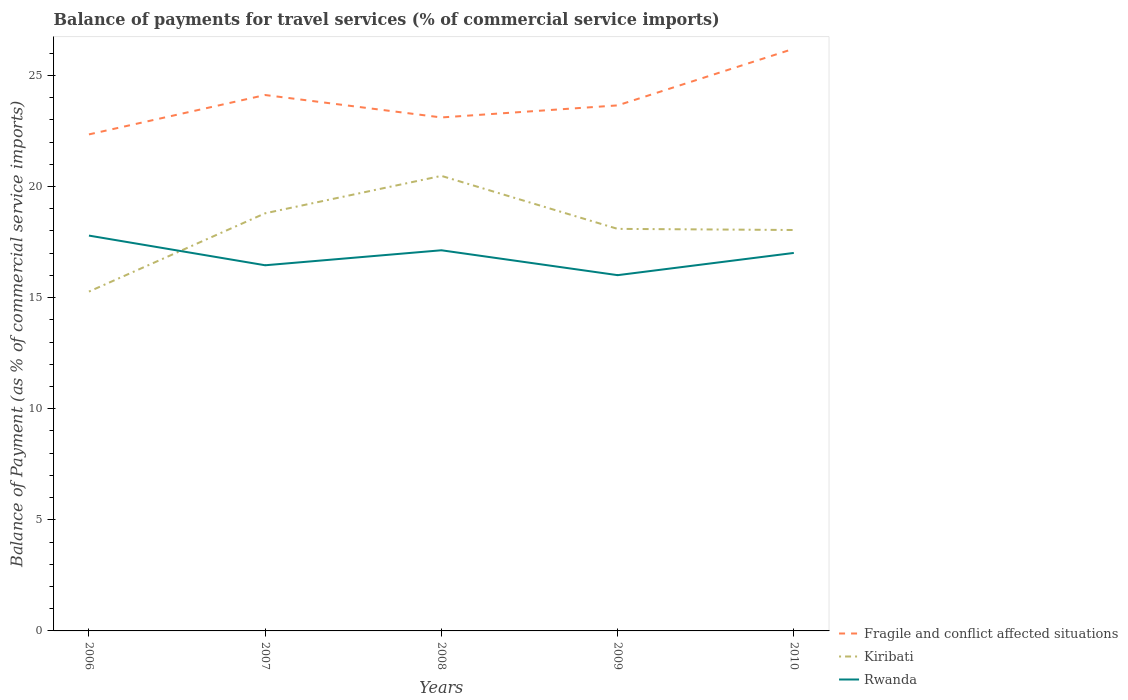How many different coloured lines are there?
Keep it short and to the point. 3. Does the line corresponding to Fragile and conflict affected situations intersect with the line corresponding to Rwanda?
Offer a very short reply. No. Is the number of lines equal to the number of legend labels?
Provide a succinct answer. Yes. Across all years, what is the maximum balance of payments for travel services in Kiribati?
Your answer should be compact. 15.27. In which year was the balance of payments for travel services in Fragile and conflict affected situations maximum?
Keep it short and to the point. 2006. What is the total balance of payments for travel services in Kiribati in the graph?
Provide a short and direct response. 2.38. What is the difference between the highest and the second highest balance of payments for travel services in Kiribati?
Give a very brief answer. 5.21. What is the difference between the highest and the lowest balance of payments for travel services in Kiribati?
Make the answer very short. 2. How many lines are there?
Give a very brief answer. 3. What is the difference between two consecutive major ticks on the Y-axis?
Your response must be concise. 5. Are the values on the major ticks of Y-axis written in scientific E-notation?
Offer a very short reply. No. Where does the legend appear in the graph?
Keep it short and to the point. Bottom right. How are the legend labels stacked?
Keep it short and to the point. Vertical. What is the title of the graph?
Your response must be concise. Balance of payments for travel services (% of commercial service imports). Does "India" appear as one of the legend labels in the graph?
Ensure brevity in your answer.  No. What is the label or title of the Y-axis?
Offer a terse response. Balance of Payment (as % of commercial service imports). What is the Balance of Payment (as % of commercial service imports) in Fragile and conflict affected situations in 2006?
Make the answer very short. 22.34. What is the Balance of Payment (as % of commercial service imports) of Kiribati in 2006?
Offer a very short reply. 15.27. What is the Balance of Payment (as % of commercial service imports) of Rwanda in 2006?
Provide a short and direct response. 17.79. What is the Balance of Payment (as % of commercial service imports) in Fragile and conflict affected situations in 2007?
Provide a short and direct response. 24.12. What is the Balance of Payment (as % of commercial service imports) in Kiribati in 2007?
Give a very brief answer. 18.79. What is the Balance of Payment (as % of commercial service imports) in Rwanda in 2007?
Your answer should be compact. 16.45. What is the Balance of Payment (as % of commercial service imports) in Fragile and conflict affected situations in 2008?
Make the answer very short. 23.11. What is the Balance of Payment (as % of commercial service imports) in Kiribati in 2008?
Ensure brevity in your answer.  20.48. What is the Balance of Payment (as % of commercial service imports) in Rwanda in 2008?
Give a very brief answer. 17.13. What is the Balance of Payment (as % of commercial service imports) in Fragile and conflict affected situations in 2009?
Your response must be concise. 23.65. What is the Balance of Payment (as % of commercial service imports) in Kiribati in 2009?
Your answer should be compact. 18.09. What is the Balance of Payment (as % of commercial service imports) in Rwanda in 2009?
Your response must be concise. 16.01. What is the Balance of Payment (as % of commercial service imports) of Fragile and conflict affected situations in 2010?
Provide a succinct answer. 26.2. What is the Balance of Payment (as % of commercial service imports) of Kiribati in 2010?
Make the answer very short. 18.04. What is the Balance of Payment (as % of commercial service imports) of Rwanda in 2010?
Your response must be concise. 17.01. Across all years, what is the maximum Balance of Payment (as % of commercial service imports) of Fragile and conflict affected situations?
Make the answer very short. 26.2. Across all years, what is the maximum Balance of Payment (as % of commercial service imports) in Kiribati?
Your response must be concise. 20.48. Across all years, what is the maximum Balance of Payment (as % of commercial service imports) of Rwanda?
Offer a very short reply. 17.79. Across all years, what is the minimum Balance of Payment (as % of commercial service imports) in Fragile and conflict affected situations?
Make the answer very short. 22.34. Across all years, what is the minimum Balance of Payment (as % of commercial service imports) of Kiribati?
Offer a terse response. 15.27. Across all years, what is the minimum Balance of Payment (as % of commercial service imports) of Rwanda?
Offer a very short reply. 16.01. What is the total Balance of Payment (as % of commercial service imports) in Fragile and conflict affected situations in the graph?
Keep it short and to the point. 119.41. What is the total Balance of Payment (as % of commercial service imports) in Kiribati in the graph?
Your answer should be very brief. 90.67. What is the total Balance of Payment (as % of commercial service imports) of Rwanda in the graph?
Your answer should be very brief. 84.39. What is the difference between the Balance of Payment (as % of commercial service imports) in Fragile and conflict affected situations in 2006 and that in 2007?
Keep it short and to the point. -1.77. What is the difference between the Balance of Payment (as % of commercial service imports) in Kiribati in 2006 and that in 2007?
Provide a short and direct response. -3.52. What is the difference between the Balance of Payment (as % of commercial service imports) of Rwanda in 2006 and that in 2007?
Provide a succinct answer. 1.34. What is the difference between the Balance of Payment (as % of commercial service imports) of Fragile and conflict affected situations in 2006 and that in 2008?
Give a very brief answer. -0.76. What is the difference between the Balance of Payment (as % of commercial service imports) of Kiribati in 2006 and that in 2008?
Provide a succinct answer. -5.21. What is the difference between the Balance of Payment (as % of commercial service imports) in Rwanda in 2006 and that in 2008?
Your response must be concise. 0.66. What is the difference between the Balance of Payment (as % of commercial service imports) of Fragile and conflict affected situations in 2006 and that in 2009?
Keep it short and to the point. -1.31. What is the difference between the Balance of Payment (as % of commercial service imports) of Kiribati in 2006 and that in 2009?
Your response must be concise. -2.82. What is the difference between the Balance of Payment (as % of commercial service imports) in Rwanda in 2006 and that in 2009?
Provide a succinct answer. 1.78. What is the difference between the Balance of Payment (as % of commercial service imports) of Fragile and conflict affected situations in 2006 and that in 2010?
Offer a terse response. -3.86. What is the difference between the Balance of Payment (as % of commercial service imports) of Kiribati in 2006 and that in 2010?
Give a very brief answer. -2.77. What is the difference between the Balance of Payment (as % of commercial service imports) in Rwanda in 2006 and that in 2010?
Keep it short and to the point. 0.78. What is the difference between the Balance of Payment (as % of commercial service imports) in Fragile and conflict affected situations in 2007 and that in 2008?
Provide a succinct answer. 1.01. What is the difference between the Balance of Payment (as % of commercial service imports) in Kiribati in 2007 and that in 2008?
Your answer should be very brief. -1.68. What is the difference between the Balance of Payment (as % of commercial service imports) in Rwanda in 2007 and that in 2008?
Offer a very short reply. -0.67. What is the difference between the Balance of Payment (as % of commercial service imports) in Fragile and conflict affected situations in 2007 and that in 2009?
Your answer should be compact. 0.47. What is the difference between the Balance of Payment (as % of commercial service imports) of Kiribati in 2007 and that in 2009?
Offer a very short reply. 0.7. What is the difference between the Balance of Payment (as % of commercial service imports) in Rwanda in 2007 and that in 2009?
Your response must be concise. 0.45. What is the difference between the Balance of Payment (as % of commercial service imports) of Fragile and conflict affected situations in 2007 and that in 2010?
Keep it short and to the point. -2.08. What is the difference between the Balance of Payment (as % of commercial service imports) of Kiribati in 2007 and that in 2010?
Ensure brevity in your answer.  0.75. What is the difference between the Balance of Payment (as % of commercial service imports) in Rwanda in 2007 and that in 2010?
Your response must be concise. -0.56. What is the difference between the Balance of Payment (as % of commercial service imports) of Fragile and conflict affected situations in 2008 and that in 2009?
Your response must be concise. -0.54. What is the difference between the Balance of Payment (as % of commercial service imports) of Kiribati in 2008 and that in 2009?
Your answer should be very brief. 2.38. What is the difference between the Balance of Payment (as % of commercial service imports) in Rwanda in 2008 and that in 2009?
Provide a succinct answer. 1.12. What is the difference between the Balance of Payment (as % of commercial service imports) of Fragile and conflict affected situations in 2008 and that in 2010?
Ensure brevity in your answer.  -3.09. What is the difference between the Balance of Payment (as % of commercial service imports) in Kiribati in 2008 and that in 2010?
Your answer should be very brief. 2.44. What is the difference between the Balance of Payment (as % of commercial service imports) of Rwanda in 2008 and that in 2010?
Provide a succinct answer. 0.12. What is the difference between the Balance of Payment (as % of commercial service imports) of Fragile and conflict affected situations in 2009 and that in 2010?
Your response must be concise. -2.55. What is the difference between the Balance of Payment (as % of commercial service imports) of Kiribati in 2009 and that in 2010?
Your answer should be very brief. 0.05. What is the difference between the Balance of Payment (as % of commercial service imports) of Rwanda in 2009 and that in 2010?
Your answer should be compact. -1. What is the difference between the Balance of Payment (as % of commercial service imports) of Fragile and conflict affected situations in 2006 and the Balance of Payment (as % of commercial service imports) of Kiribati in 2007?
Give a very brief answer. 3.55. What is the difference between the Balance of Payment (as % of commercial service imports) in Fragile and conflict affected situations in 2006 and the Balance of Payment (as % of commercial service imports) in Rwanda in 2007?
Your response must be concise. 5.89. What is the difference between the Balance of Payment (as % of commercial service imports) in Kiribati in 2006 and the Balance of Payment (as % of commercial service imports) in Rwanda in 2007?
Ensure brevity in your answer.  -1.18. What is the difference between the Balance of Payment (as % of commercial service imports) in Fragile and conflict affected situations in 2006 and the Balance of Payment (as % of commercial service imports) in Kiribati in 2008?
Offer a very short reply. 1.87. What is the difference between the Balance of Payment (as % of commercial service imports) of Fragile and conflict affected situations in 2006 and the Balance of Payment (as % of commercial service imports) of Rwanda in 2008?
Give a very brief answer. 5.21. What is the difference between the Balance of Payment (as % of commercial service imports) in Kiribati in 2006 and the Balance of Payment (as % of commercial service imports) in Rwanda in 2008?
Your answer should be compact. -1.86. What is the difference between the Balance of Payment (as % of commercial service imports) in Fragile and conflict affected situations in 2006 and the Balance of Payment (as % of commercial service imports) in Kiribati in 2009?
Provide a short and direct response. 4.25. What is the difference between the Balance of Payment (as % of commercial service imports) of Fragile and conflict affected situations in 2006 and the Balance of Payment (as % of commercial service imports) of Rwanda in 2009?
Offer a very short reply. 6.33. What is the difference between the Balance of Payment (as % of commercial service imports) of Kiribati in 2006 and the Balance of Payment (as % of commercial service imports) of Rwanda in 2009?
Your response must be concise. -0.74. What is the difference between the Balance of Payment (as % of commercial service imports) in Fragile and conflict affected situations in 2006 and the Balance of Payment (as % of commercial service imports) in Kiribati in 2010?
Your response must be concise. 4.3. What is the difference between the Balance of Payment (as % of commercial service imports) of Fragile and conflict affected situations in 2006 and the Balance of Payment (as % of commercial service imports) of Rwanda in 2010?
Your answer should be very brief. 5.33. What is the difference between the Balance of Payment (as % of commercial service imports) of Kiribati in 2006 and the Balance of Payment (as % of commercial service imports) of Rwanda in 2010?
Make the answer very short. -1.74. What is the difference between the Balance of Payment (as % of commercial service imports) of Fragile and conflict affected situations in 2007 and the Balance of Payment (as % of commercial service imports) of Kiribati in 2008?
Offer a very short reply. 3.64. What is the difference between the Balance of Payment (as % of commercial service imports) in Fragile and conflict affected situations in 2007 and the Balance of Payment (as % of commercial service imports) in Rwanda in 2008?
Ensure brevity in your answer.  6.99. What is the difference between the Balance of Payment (as % of commercial service imports) of Kiribati in 2007 and the Balance of Payment (as % of commercial service imports) of Rwanda in 2008?
Offer a terse response. 1.66. What is the difference between the Balance of Payment (as % of commercial service imports) in Fragile and conflict affected situations in 2007 and the Balance of Payment (as % of commercial service imports) in Kiribati in 2009?
Make the answer very short. 6.02. What is the difference between the Balance of Payment (as % of commercial service imports) in Fragile and conflict affected situations in 2007 and the Balance of Payment (as % of commercial service imports) in Rwanda in 2009?
Offer a very short reply. 8.11. What is the difference between the Balance of Payment (as % of commercial service imports) of Kiribati in 2007 and the Balance of Payment (as % of commercial service imports) of Rwanda in 2009?
Give a very brief answer. 2.78. What is the difference between the Balance of Payment (as % of commercial service imports) in Fragile and conflict affected situations in 2007 and the Balance of Payment (as % of commercial service imports) in Kiribati in 2010?
Your response must be concise. 6.07. What is the difference between the Balance of Payment (as % of commercial service imports) of Fragile and conflict affected situations in 2007 and the Balance of Payment (as % of commercial service imports) of Rwanda in 2010?
Give a very brief answer. 7.11. What is the difference between the Balance of Payment (as % of commercial service imports) of Kiribati in 2007 and the Balance of Payment (as % of commercial service imports) of Rwanda in 2010?
Offer a terse response. 1.78. What is the difference between the Balance of Payment (as % of commercial service imports) in Fragile and conflict affected situations in 2008 and the Balance of Payment (as % of commercial service imports) in Kiribati in 2009?
Offer a terse response. 5.01. What is the difference between the Balance of Payment (as % of commercial service imports) in Fragile and conflict affected situations in 2008 and the Balance of Payment (as % of commercial service imports) in Rwanda in 2009?
Offer a very short reply. 7.1. What is the difference between the Balance of Payment (as % of commercial service imports) in Kiribati in 2008 and the Balance of Payment (as % of commercial service imports) in Rwanda in 2009?
Your answer should be very brief. 4.47. What is the difference between the Balance of Payment (as % of commercial service imports) in Fragile and conflict affected situations in 2008 and the Balance of Payment (as % of commercial service imports) in Kiribati in 2010?
Your answer should be very brief. 5.06. What is the difference between the Balance of Payment (as % of commercial service imports) of Fragile and conflict affected situations in 2008 and the Balance of Payment (as % of commercial service imports) of Rwanda in 2010?
Keep it short and to the point. 6.1. What is the difference between the Balance of Payment (as % of commercial service imports) in Kiribati in 2008 and the Balance of Payment (as % of commercial service imports) in Rwanda in 2010?
Offer a very short reply. 3.47. What is the difference between the Balance of Payment (as % of commercial service imports) of Fragile and conflict affected situations in 2009 and the Balance of Payment (as % of commercial service imports) of Kiribati in 2010?
Offer a very short reply. 5.61. What is the difference between the Balance of Payment (as % of commercial service imports) in Fragile and conflict affected situations in 2009 and the Balance of Payment (as % of commercial service imports) in Rwanda in 2010?
Your response must be concise. 6.64. What is the difference between the Balance of Payment (as % of commercial service imports) in Kiribati in 2009 and the Balance of Payment (as % of commercial service imports) in Rwanda in 2010?
Keep it short and to the point. 1.08. What is the average Balance of Payment (as % of commercial service imports) of Fragile and conflict affected situations per year?
Offer a terse response. 23.88. What is the average Balance of Payment (as % of commercial service imports) of Kiribati per year?
Provide a short and direct response. 18.13. What is the average Balance of Payment (as % of commercial service imports) in Rwanda per year?
Your answer should be compact. 16.88. In the year 2006, what is the difference between the Balance of Payment (as % of commercial service imports) of Fragile and conflict affected situations and Balance of Payment (as % of commercial service imports) of Kiribati?
Provide a succinct answer. 7.07. In the year 2006, what is the difference between the Balance of Payment (as % of commercial service imports) in Fragile and conflict affected situations and Balance of Payment (as % of commercial service imports) in Rwanda?
Ensure brevity in your answer.  4.55. In the year 2006, what is the difference between the Balance of Payment (as % of commercial service imports) in Kiribati and Balance of Payment (as % of commercial service imports) in Rwanda?
Keep it short and to the point. -2.52. In the year 2007, what is the difference between the Balance of Payment (as % of commercial service imports) of Fragile and conflict affected situations and Balance of Payment (as % of commercial service imports) of Kiribati?
Provide a short and direct response. 5.32. In the year 2007, what is the difference between the Balance of Payment (as % of commercial service imports) in Fragile and conflict affected situations and Balance of Payment (as % of commercial service imports) in Rwanda?
Your answer should be compact. 7.66. In the year 2007, what is the difference between the Balance of Payment (as % of commercial service imports) in Kiribati and Balance of Payment (as % of commercial service imports) in Rwanda?
Ensure brevity in your answer.  2.34. In the year 2008, what is the difference between the Balance of Payment (as % of commercial service imports) of Fragile and conflict affected situations and Balance of Payment (as % of commercial service imports) of Kiribati?
Offer a terse response. 2.63. In the year 2008, what is the difference between the Balance of Payment (as % of commercial service imports) of Fragile and conflict affected situations and Balance of Payment (as % of commercial service imports) of Rwanda?
Offer a terse response. 5.98. In the year 2008, what is the difference between the Balance of Payment (as % of commercial service imports) of Kiribati and Balance of Payment (as % of commercial service imports) of Rwanda?
Offer a very short reply. 3.35. In the year 2009, what is the difference between the Balance of Payment (as % of commercial service imports) in Fragile and conflict affected situations and Balance of Payment (as % of commercial service imports) in Kiribati?
Your answer should be very brief. 5.56. In the year 2009, what is the difference between the Balance of Payment (as % of commercial service imports) of Fragile and conflict affected situations and Balance of Payment (as % of commercial service imports) of Rwanda?
Your answer should be compact. 7.64. In the year 2009, what is the difference between the Balance of Payment (as % of commercial service imports) of Kiribati and Balance of Payment (as % of commercial service imports) of Rwanda?
Your response must be concise. 2.08. In the year 2010, what is the difference between the Balance of Payment (as % of commercial service imports) of Fragile and conflict affected situations and Balance of Payment (as % of commercial service imports) of Kiribati?
Your answer should be compact. 8.16. In the year 2010, what is the difference between the Balance of Payment (as % of commercial service imports) in Fragile and conflict affected situations and Balance of Payment (as % of commercial service imports) in Rwanda?
Keep it short and to the point. 9.19. In the year 2010, what is the difference between the Balance of Payment (as % of commercial service imports) of Kiribati and Balance of Payment (as % of commercial service imports) of Rwanda?
Provide a succinct answer. 1.03. What is the ratio of the Balance of Payment (as % of commercial service imports) of Fragile and conflict affected situations in 2006 to that in 2007?
Make the answer very short. 0.93. What is the ratio of the Balance of Payment (as % of commercial service imports) in Kiribati in 2006 to that in 2007?
Offer a very short reply. 0.81. What is the ratio of the Balance of Payment (as % of commercial service imports) of Rwanda in 2006 to that in 2007?
Your answer should be compact. 1.08. What is the ratio of the Balance of Payment (as % of commercial service imports) in Kiribati in 2006 to that in 2008?
Your response must be concise. 0.75. What is the ratio of the Balance of Payment (as % of commercial service imports) in Rwanda in 2006 to that in 2008?
Offer a terse response. 1.04. What is the ratio of the Balance of Payment (as % of commercial service imports) of Fragile and conflict affected situations in 2006 to that in 2009?
Provide a short and direct response. 0.94. What is the ratio of the Balance of Payment (as % of commercial service imports) of Kiribati in 2006 to that in 2009?
Provide a succinct answer. 0.84. What is the ratio of the Balance of Payment (as % of commercial service imports) of Rwanda in 2006 to that in 2009?
Your response must be concise. 1.11. What is the ratio of the Balance of Payment (as % of commercial service imports) of Fragile and conflict affected situations in 2006 to that in 2010?
Your response must be concise. 0.85. What is the ratio of the Balance of Payment (as % of commercial service imports) of Kiribati in 2006 to that in 2010?
Offer a very short reply. 0.85. What is the ratio of the Balance of Payment (as % of commercial service imports) in Rwanda in 2006 to that in 2010?
Your answer should be compact. 1.05. What is the ratio of the Balance of Payment (as % of commercial service imports) of Fragile and conflict affected situations in 2007 to that in 2008?
Offer a very short reply. 1.04. What is the ratio of the Balance of Payment (as % of commercial service imports) of Kiribati in 2007 to that in 2008?
Your response must be concise. 0.92. What is the ratio of the Balance of Payment (as % of commercial service imports) in Rwanda in 2007 to that in 2008?
Your response must be concise. 0.96. What is the ratio of the Balance of Payment (as % of commercial service imports) of Fragile and conflict affected situations in 2007 to that in 2009?
Offer a very short reply. 1.02. What is the ratio of the Balance of Payment (as % of commercial service imports) in Kiribati in 2007 to that in 2009?
Your answer should be compact. 1.04. What is the ratio of the Balance of Payment (as % of commercial service imports) of Rwanda in 2007 to that in 2009?
Your response must be concise. 1.03. What is the ratio of the Balance of Payment (as % of commercial service imports) in Fragile and conflict affected situations in 2007 to that in 2010?
Ensure brevity in your answer.  0.92. What is the ratio of the Balance of Payment (as % of commercial service imports) in Kiribati in 2007 to that in 2010?
Offer a terse response. 1.04. What is the ratio of the Balance of Payment (as % of commercial service imports) of Rwanda in 2007 to that in 2010?
Provide a succinct answer. 0.97. What is the ratio of the Balance of Payment (as % of commercial service imports) in Fragile and conflict affected situations in 2008 to that in 2009?
Ensure brevity in your answer.  0.98. What is the ratio of the Balance of Payment (as % of commercial service imports) in Kiribati in 2008 to that in 2009?
Offer a terse response. 1.13. What is the ratio of the Balance of Payment (as % of commercial service imports) of Rwanda in 2008 to that in 2009?
Your answer should be compact. 1.07. What is the ratio of the Balance of Payment (as % of commercial service imports) in Fragile and conflict affected situations in 2008 to that in 2010?
Make the answer very short. 0.88. What is the ratio of the Balance of Payment (as % of commercial service imports) in Kiribati in 2008 to that in 2010?
Offer a very short reply. 1.14. What is the ratio of the Balance of Payment (as % of commercial service imports) of Fragile and conflict affected situations in 2009 to that in 2010?
Make the answer very short. 0.9. What is the ratio of the Balance of Payment (as % of commercial service imports) in Rwanda in 2009 to that in 2010?
Provide a succinct answer. 0.94. What is the difference between the highest and the second highest Balance of Payment (as % of commercial service imports) of Fragile and conflict affected situations?
Provide a short and direct response. 2.08. What is the difference between the highest and the second highest Balance of Payment (as % of commercial service imports) of Kiribati?
Make the answer very short. 1.68. What is the difference between the highest and the second highest Balance of Payment (as % of commercial service imports) of Rwanda?
Ensure brevity in your answer.  0.66. What is the difference between the highest and the lowest Balance of Payment (as % of commercial service imports) in Fragile and conflict affected situations?
Make the answer very short. 3.86. What is the difference between the highest and the lowest Balance of Payment (as % of commercial service imports) in Kiribati?
Provide a succinct answer. 5.21. What is the difference between the highest and the lowest Balance of Payment (as % of commercial service imports) in Rwanda?
Your answer should be compact. 1.78. 